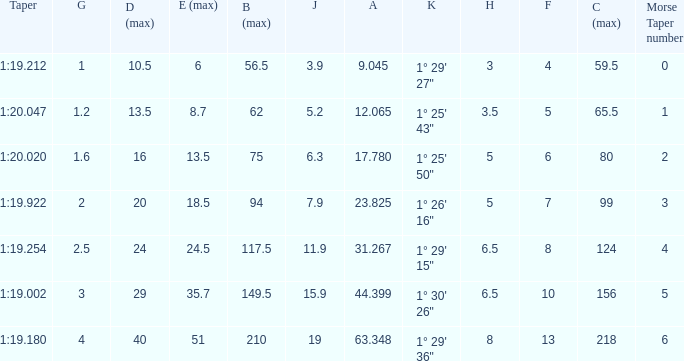Name the least morse taper number when taper is 1:20.047 1.0. 